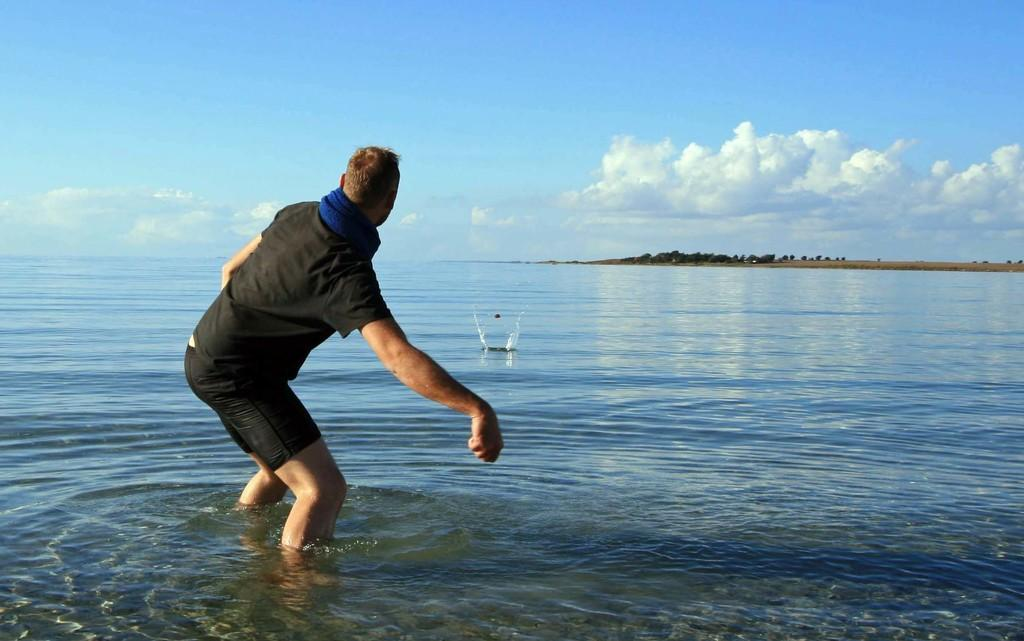What is at the bottom of the image? There is water at the bottom of the image. Who or what is in the water? A man is standing in the water. What can be seen at the top of the image? There are trees and clouds at the top of the image. What else is visible at the top of the image? The sky is visible at the top of the image. How many carts are visible in the image? There are no carts present in the image. Can you tell me where the man sneezes in the image? There is no indication of the man sneezing in the image. 